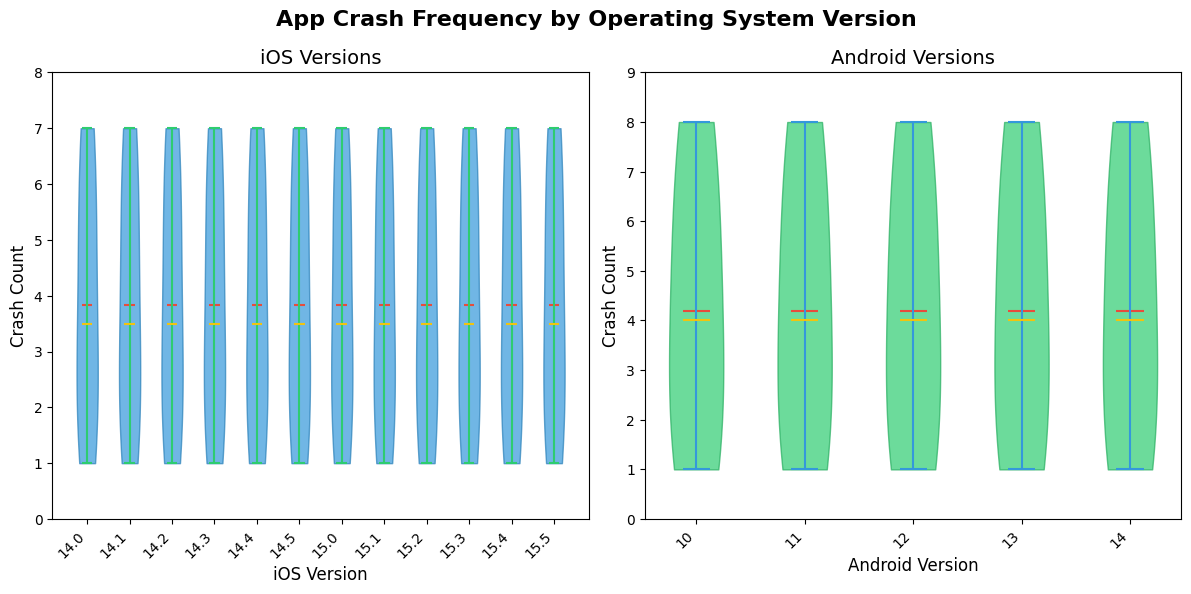What is the title of the figure? The title of the figure is at the top center and reads "App Crash Frequency by Operating System Version".
Answer: App Crash Frequency by Operating System Version What do the colors represent in the violin plots? The colors differentiate the platforms: blue and green for the violin bodies of iOS and Android respectively. Additionally, the means are marked in red, extrema in green/blue, and medians in yellow.
Answer: iOS in blue, Android in green; means in red, extrema in green/blue, medians in yellow How does iOS_14.0 compare to iOS_15.5 in terms of crash counts? By observing the y-axis on the iOS violin plot, iOS_14.0 has a crash count of 5, while iOS_15.5 has a crash count of 1, so iOS_14.0 has more crashes.
Answer: iOS_14.0 has more crashes Which operating system version has the highest crash count? By examining the y-axis and length of the violin plots, Android_10 has the highest crash count, which is 8.
Answer: Android_10 Are the crash count distributions symmetric for iOS and Android versions? The violin plots are symmetric around their center axes for both iOS and Android versions, indicating a symmetrical distribution.
Answer: Yes What’s the range of crash counts for Android versions? The highest crash count for Android (Android_10) is 8 and the lowest (Android_14) is 1. So, the range is 8 - 1 = 7.
Answer: 7 What's the mean crash count for iOS versions? The means are visually indicated by a red line within the violins. Summing the crash counts: 5 + 7 + 3 + 6 + 2 + 1 + 4 + 5 + 3 + 7 + 2 + 1 = 46, and there are 12 data points. The mean is 46/12 ≈ 3.83.
Answer: Approximately 3.83 Which iOS version has a lower median crash count, iOS_14.* or iOS_15.*? The medians are displayed as yellow lines in the violin plots. Comparing the two categories, iOS_14.* has a lower median crash count compared to iOS_15.* because the central yellow line in iOS_14.* is positioned lower on the y-axis.
Answer: iOS_14.* Is there any operating system version with a crash count of exactly 7? By looking at the y-axis markers, iOS_14.1, iOS_15.3, and iOS_14.3 all have crash counts of exactly 7.
Answer: Yes, iOS_14.1, iOS_15.3, and iOS_14.3 Are there any crash counts that only appear once among Android versions? Observing the Android violin plot, crash counts such as 2 (Android_12) and 1 (Android_14) appear only once.
Answer: Yes, 2 and 1 